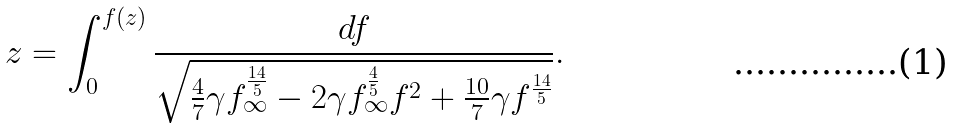<formula> <loc_0><loc_0><loc_500><loc_500>z = \int _ { 0 } ^ { f ( z ) } \frac { d f } { \sqrt { \frac { 4 } { 7 } \gamma f _ { \infty } ^ { \frac { 1 4 } { 5 } } - 2 \gamma f _ { \infty } ^ { \frac { 4 } { 5 } } f ^ { 2 } + \frac { 1 0 } { 7 } \gamma f ^ { \frac { 1 4 } { 5 } } } } .</formula> 